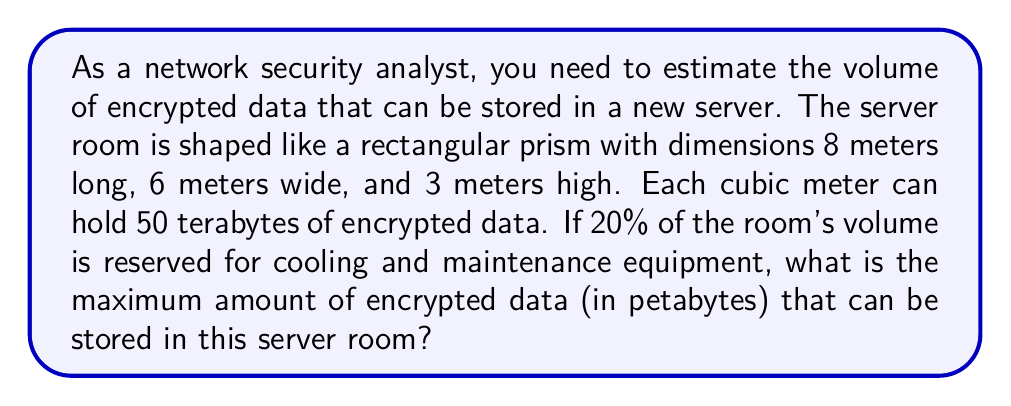Can you answer this question? Let's approach this problem step-by-step:

1) First, calculate the total volume of the server room:
   $$ V = l \times w \times h $$
   $$ V = 8 \text{ m} \times 6 \text{ m} \times 3 \text{ m} = 144 \text{ m}^3 $$

2) Now, consider that 20% of this volume is reserved for cooling and maintenance:
   $$ V_{\text{available}} = 80\% \text{ of total volume} $$
   $$ V_{\text{available}} = 0.80 \times 144 \text{ m}^3 = 115.2 \text{ m}^3 $$

3) We're told that each cubic meter can hold 50 terabytes of encrypted data:
   $$ \text{Data per m}^3 = 50 \text{ TB} $$

4) Calculate the total data capacity:
   $$ \text{Total data} = V_{\text{available}} \times \text{Data per m}^3 $$
   $$ \text{Total data} = 115.2 \text{ m}^3 \times 50 \text{ TB/m}^3 = 5,760 \text{ TB} $$

5) Convert terabytes to petabytes:
   $$ 1 \text{ PB} = 1,000 \text{ TB} $$
   $$ \text{Total data in PB} = \frac{5,760 \text{ TB}}{1,000 \text{ TB/PB}} = 5.76 \text{ PB} $$

Therefore, the maximum amount of encrypted data that can be stored is 5.76 petabytes.
Answer: 5.76 petabytes 